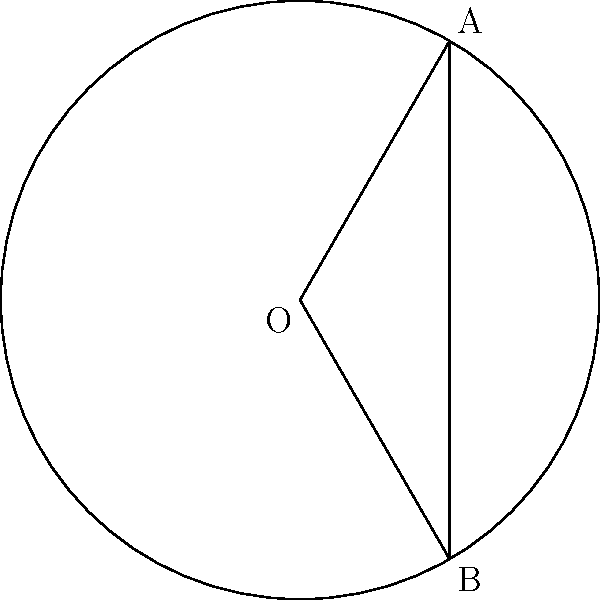In a brain imaging study of the frontal lobe, a circular segment is identified as shown in the figure. The radius of the brain slice is 6 cm, and the central angle of the segment is 120°. Calculate the area of the frontal lobe segment to the nearest 0.01 cm². (Use $\pi \approx 3.14$) To calculate the area of the circular segment (frontal lobe section), we need to:

1) Calculate the area of the sector:
   $A_{sector} = \frac{\theta}{360°} \pi r^2$
   Where $\theta = 120°$ and $r = 6$ cm
   $A_{sector} = \frac{120}{360} \times 3.14 \times 6^2 = 37.68$ cm²

2) Calculate the area of the triangle:
   $A_{triangle} = \frac{1}{2} r^2 \sin(\theta)$
   $A_{triangle} = \frac{1}{2} \times 6^2 \times \sin(120°) = 15.588$ cm²

3) The area of the segment is the difference:
   $A_{segment} = A_{sector} - A_{triangle}$
   $A_{segment} = 37.68 - 15.588 = 22.092$ cm²

4) Rounding to the nearest 0.01:
   $A_{segment} \approx 22.09$ cm²
Answer: 22.09 cm² 